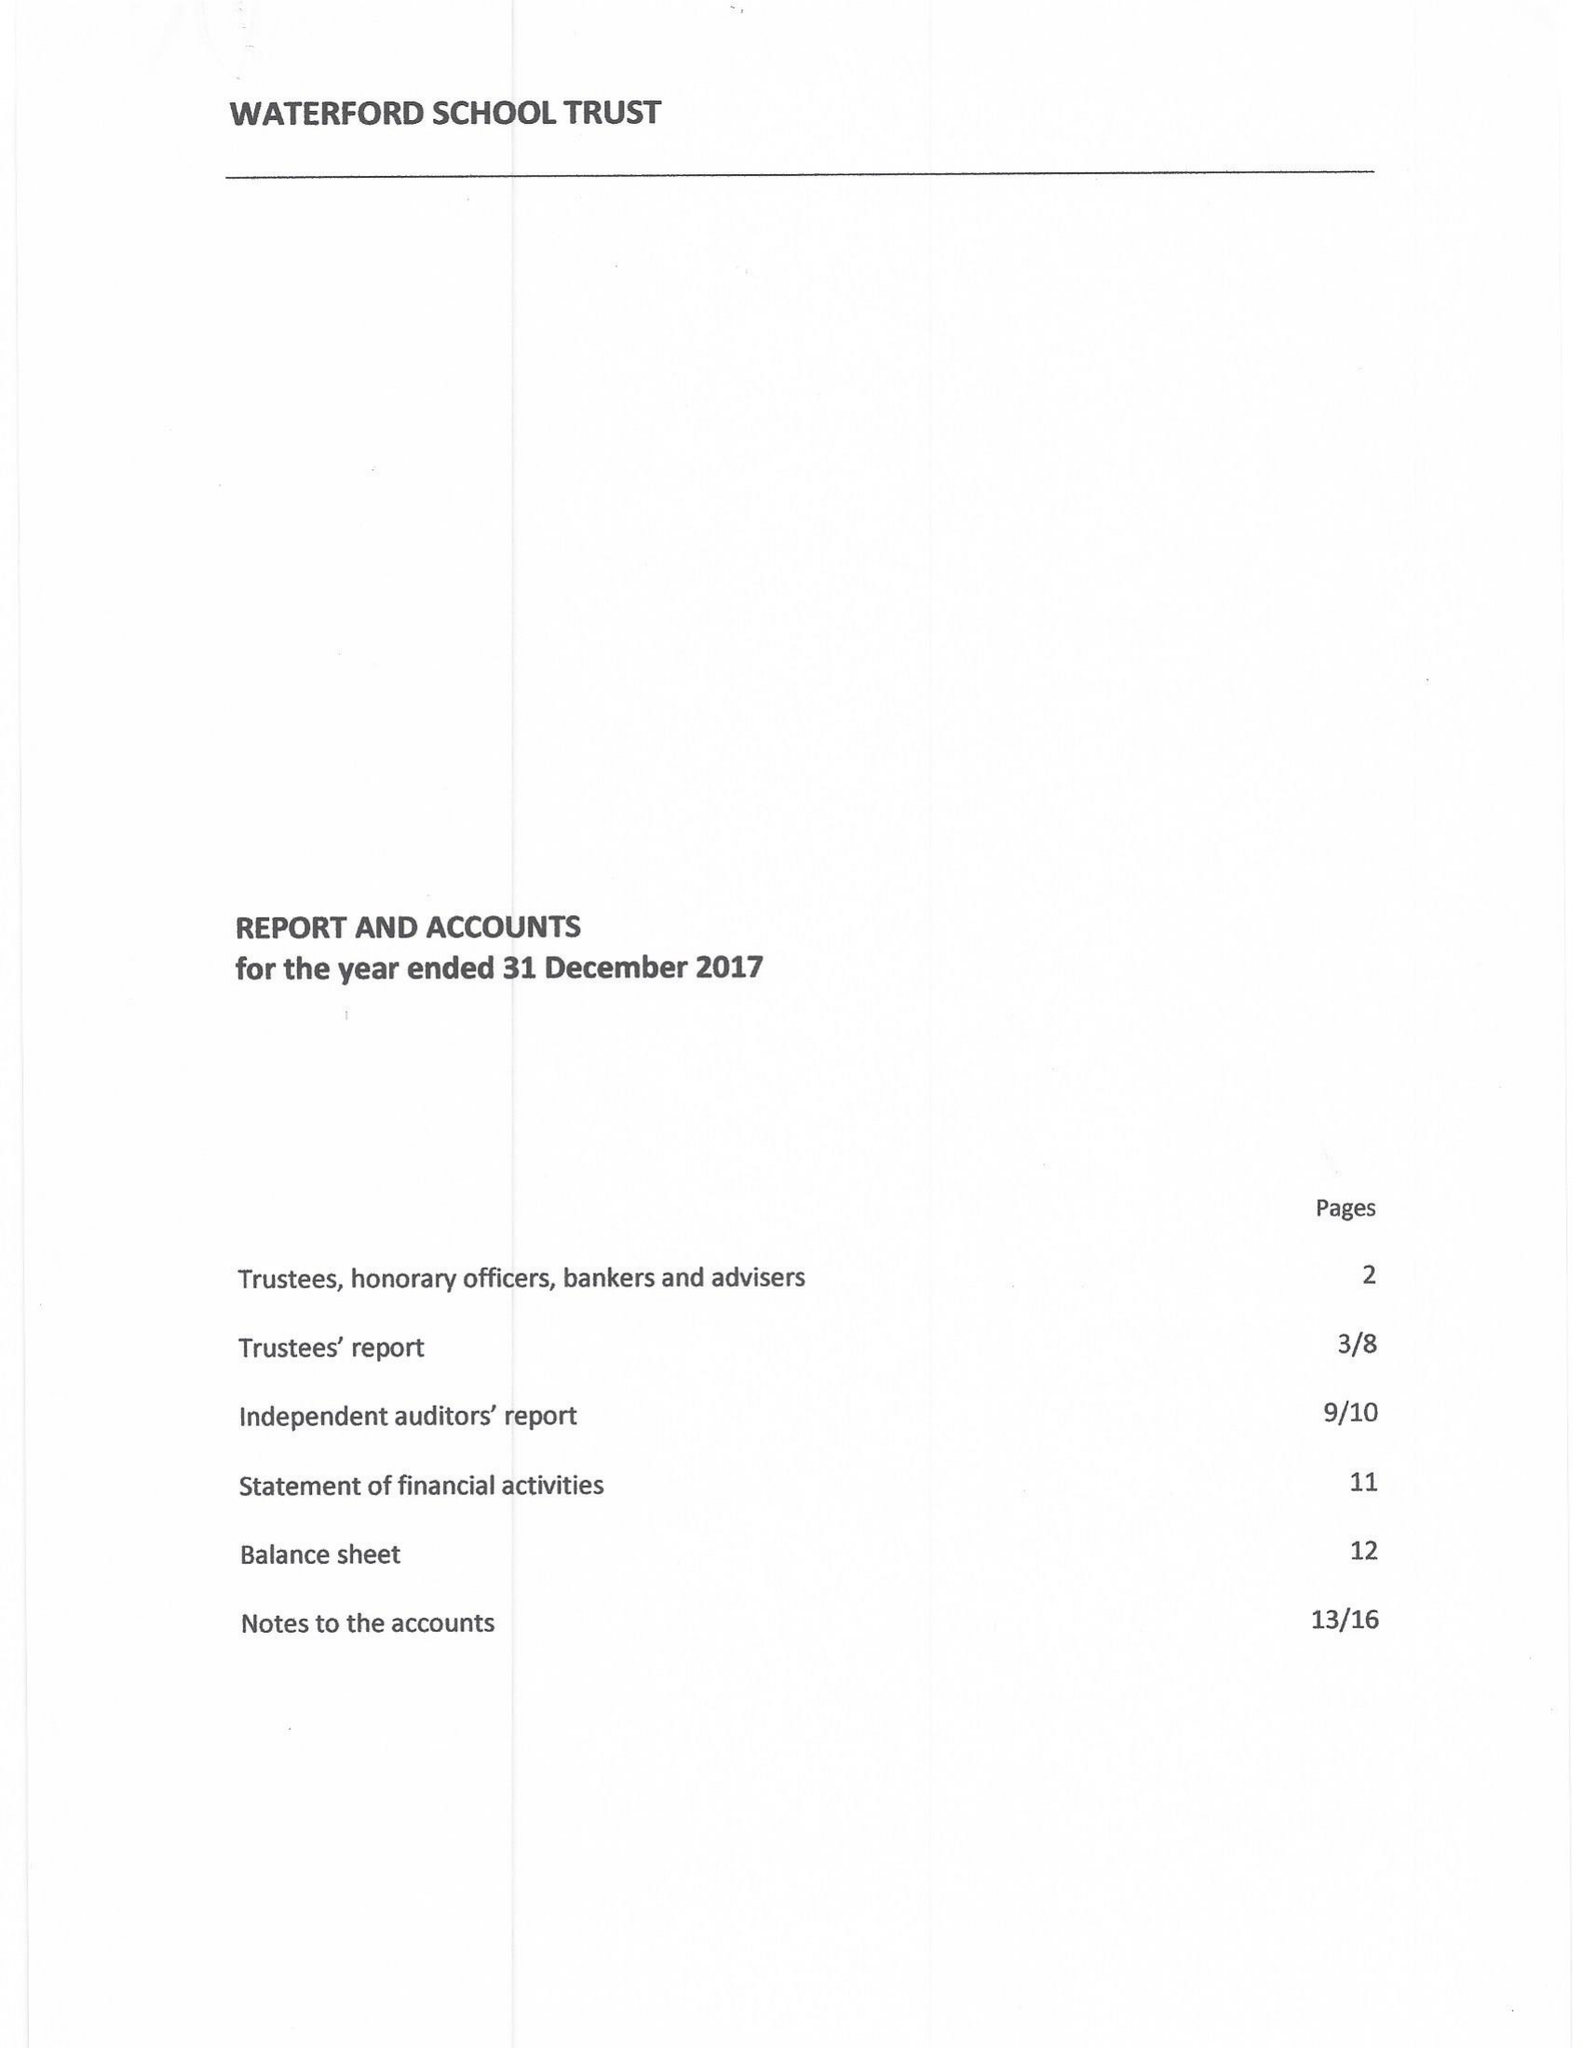What is the value for the charity_name?
Answer the question using a single word or phrase. Waterford School Trust 